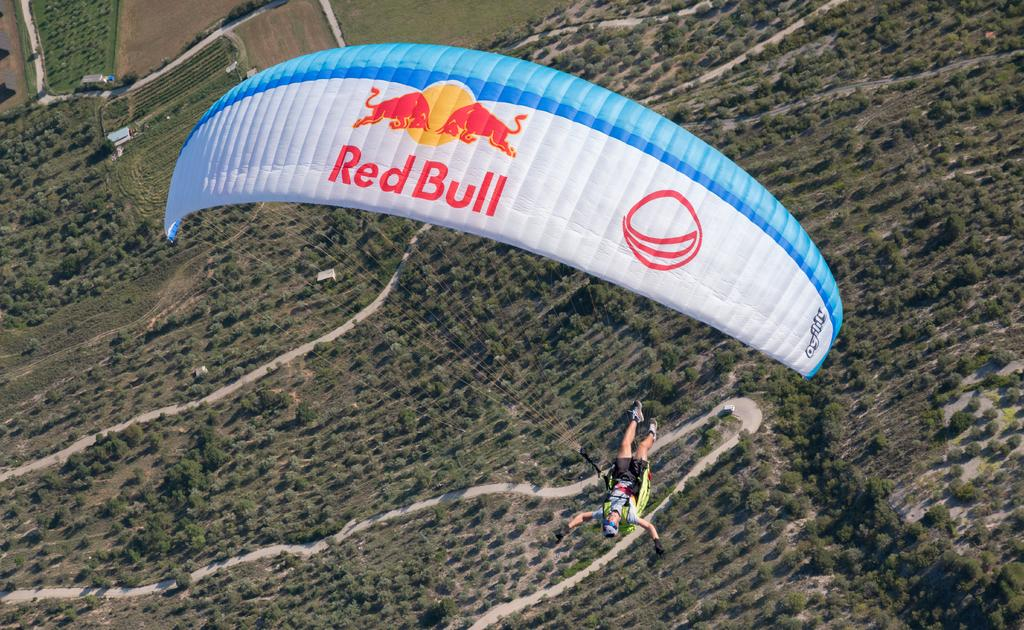What is the person in the image doing? The person is flying with the help of a parachute. What can be seen in the background of the image? There are trees, houses, and grass visible in the image. Can you see any sea or ocean in the image? No, there is no sea or ocean visible in the image. What type of cracker is being used by the person flying with a parachute? There is no cracker present in the image. 